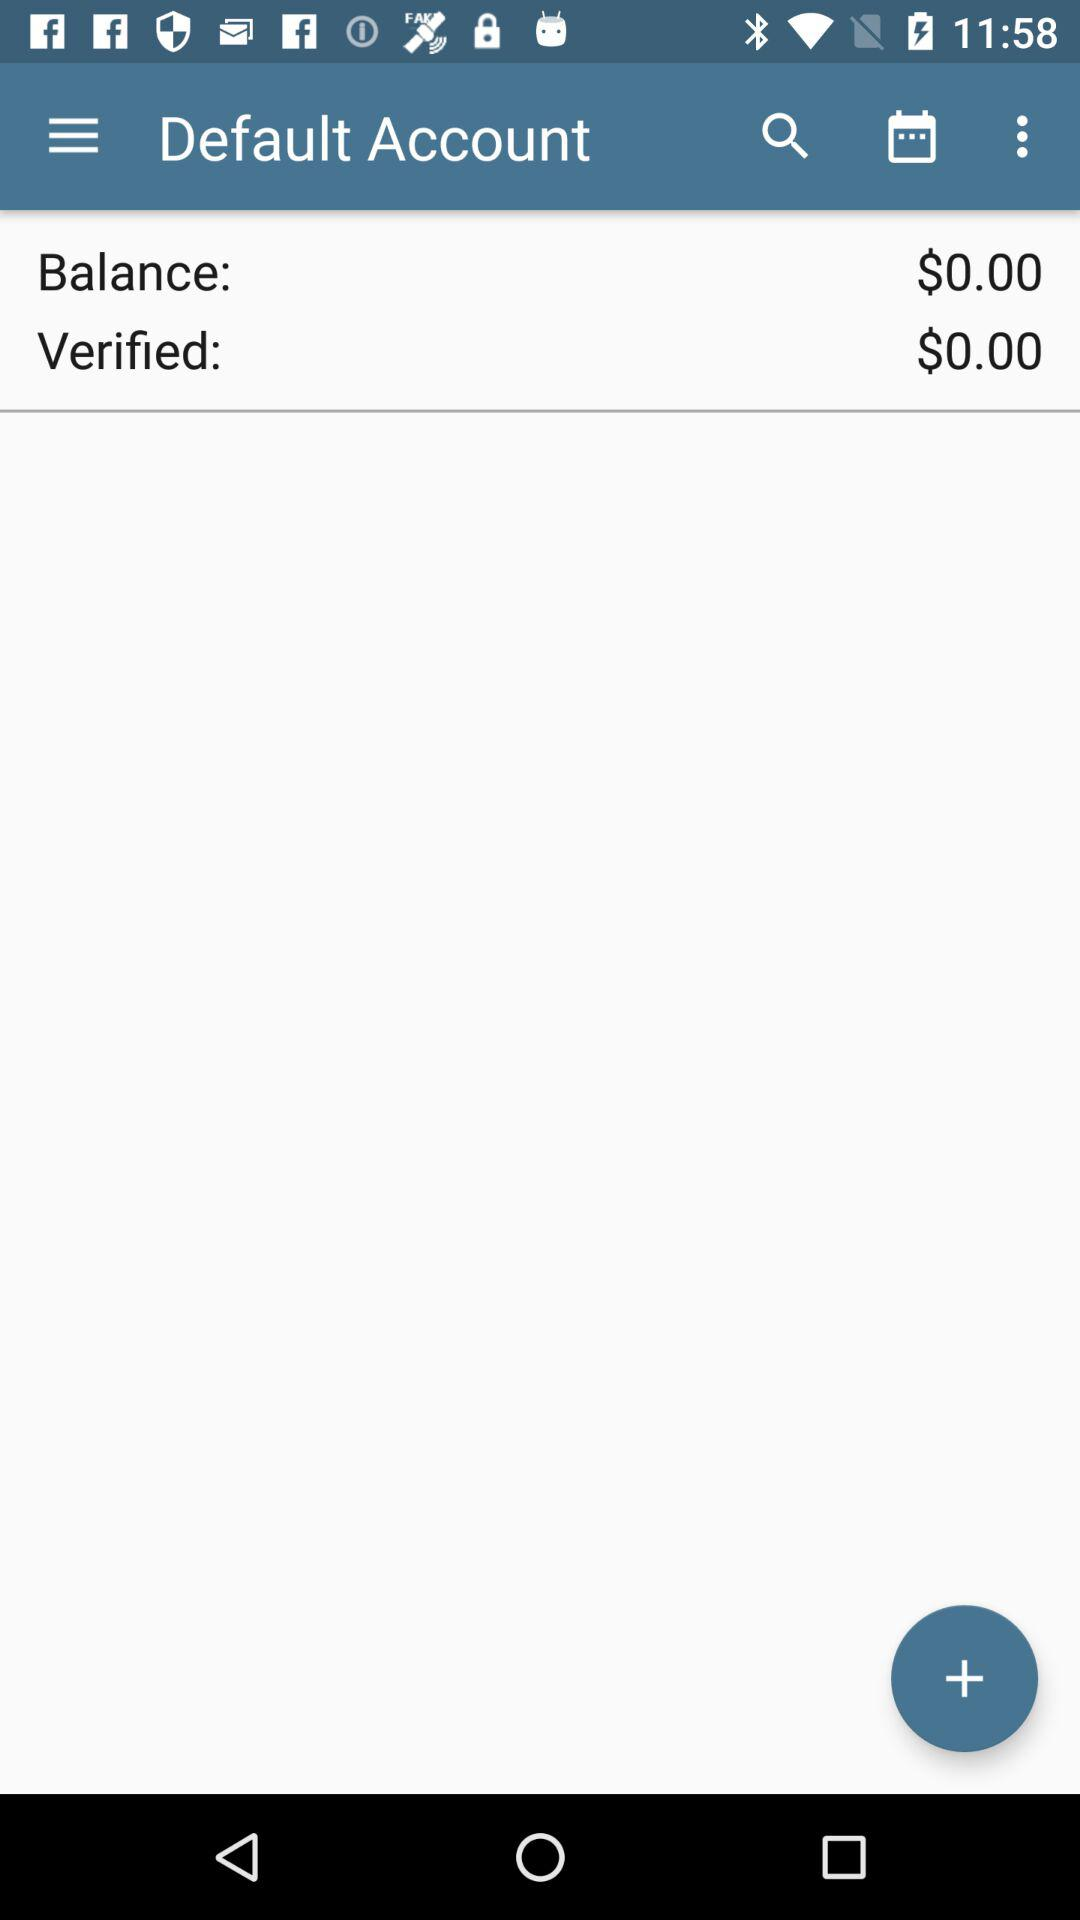What is the verified amount? The verified amount is $0.00. 